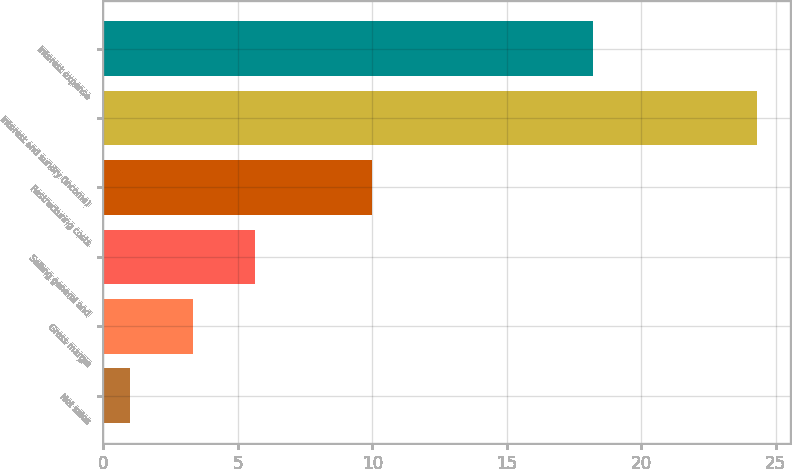Convert chart. <chart><loc_0><loc_0><loc_500><loc_500><bar_chart><fcel>Net sales<fcel>Gross margin<fcel>Selling general and<fcel>Restructuring costs<fcel>Interest and sundry (income)<fcel>Interest expense<nl><fcel>1<fcel>3.33<fcel>5.66<fcel>10<fcel>24.3<fcel>18.2<nl></chart> 